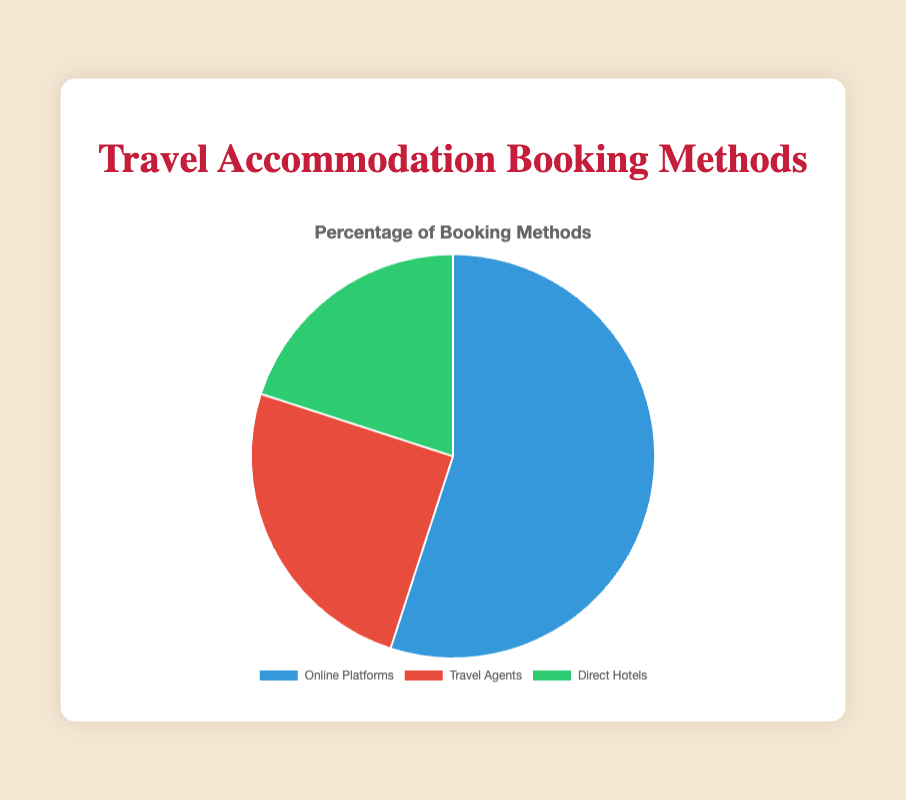Which method is used by the highest percentage of people to book travel accommodations? The pie chart shows three methods of booking travel accommodations with their respective percentages. The largest segment corresponds to Online Platforms at 55%.
Answer: Online Platforms What is the combined percentage of people using Travel Agents and Direct Hotels? To find the combined percentage, add the percentage of people using Travel Agents (25%) and Direct Hotels (20%). The sum is 25% + 20% = 45%.
Answer: 45% How does the percentage of people booking through Travel Agents compare to those booking directly with hotels? Compare the percentage values for Travel Agents (25%) and Direct Hotels (20%). Since 25% is greater than 20%, more people use Travel Agents than book directly with hotels.
Answer: More people use Travel Agents What fraction of people book their accommodations through Online Platforms? The percentage of people using Online Platforms is 55%. In fractional terms, this is 55/100, which simplifies to 11/20.
Answer: 11/20 If 2000 people were surveyed, how many would have booked through Online Platforms? To find this, multiply the total number of people (2000) by the percentage that use Online Platforms (55%), or 2000 * 0.55 = 1100.
Answer: 1100 Which segment is represented by the color red in the pie chart? The color red in the pie chart represents the Travel Agents method. This can be inferred from the position and color assignment in the legend.
Answer: Travel Agents Is the proportion of people using Online Platforms greater than the sum of those using Travel Agents and Direct Hotels? Calculate the proportion of Online Platforms (55%) and compare it to the combined proportion of Travel Agents (25%) and Direct Hotels (20%). Specifically, 55% is compared with 25% + 20% = 45%. Since 55% > 45%, the proportion using Online Platforms is indeed greater.
Answer: Yes What is the ratio of people booking via Online Platforms to those booking via Travel Agents? The percentage of people using Online Platforms is 55% and Travel Agents is 25%. The ratio is 55/25 which simplifies to 11/5.
Answer: 11:5 How many more people would need to use Direct Hotels to equal those using Travel Agents if the survey was of 1000 people? First calculate the number of people using Travel Agents and Direct Hotels out of 1000: Travel Agents = 1000 * 0.25 = 250, Direct Hotels = 1000 * 0.20 = 200. The difference is 250 - 200 = 50. Therefore, 50 more people would need to use Direct Hotels.
Answer: 50 